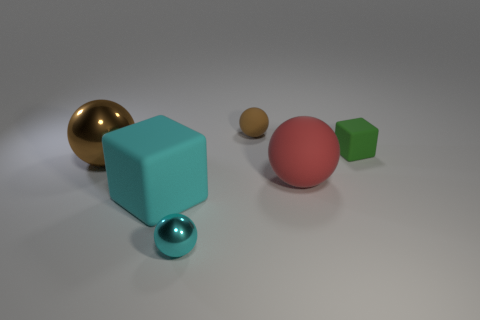Add 1 big cyan spheres. How many objects exist? 7 Subtract all balls. How many objects are left? 2 Add 5 big blue shiny blocks. How many big blue shiny blocks exist? 5 Subtract 0 green balls. How many objects are left? 6 Subtract all big cyan objects. Subtract all tiny rubber cubes. How many objects are left? 4 Add 3 small cyan balls. How many small cyan balls are left? 4 